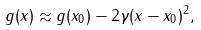Convert formula to latex. <formula><loc_0><loc_0><loc_500><loc_500>g ( x ) \approx g ( x _ { 0 } ) - 2 \gamma ( x - x _ { 0 } ) ^ { 2 } ,</formula> 